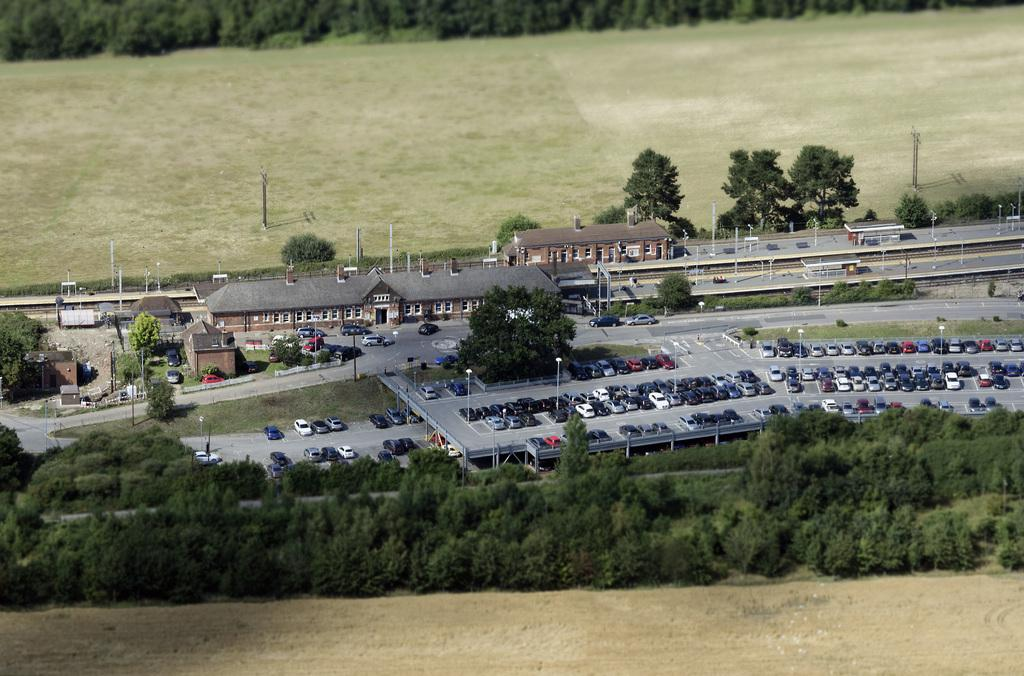What type of vegetation can be seen in the image? There are trees in the image. What mode of transportation can be seen on the road in the image? There are cars on the road in the image. What type of structures are visible in the image? There are houses and buildings in the image. What can be seen in the background of the image? Trees are visible in the background of the image. What degree of difficulty is the tongue facing in the image? There is no tongue present in the image, so it is not possible to determine the degree of difficulty it might be facing. What type of amusement can be seen in the image? There is no amusement park or any amusement-related objects present in the image. 